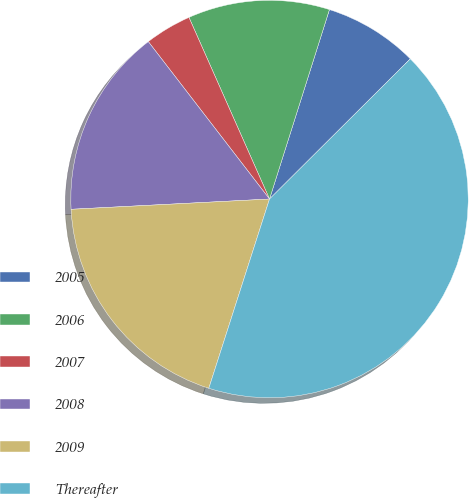Convert chart. <chart><loc_0><loc_0><loc_500><loc_500><pie_chart><fcel>2005<fcel>2006<fcel>2007<fcel>2008<fcel>2009<fcel>Thereafter<nl><fcel>7.66%<fcel>11.52%<fcel>3.8%<fcel>15.38%<fcel>19.24%<fcel>42.41%<nl></chart> 